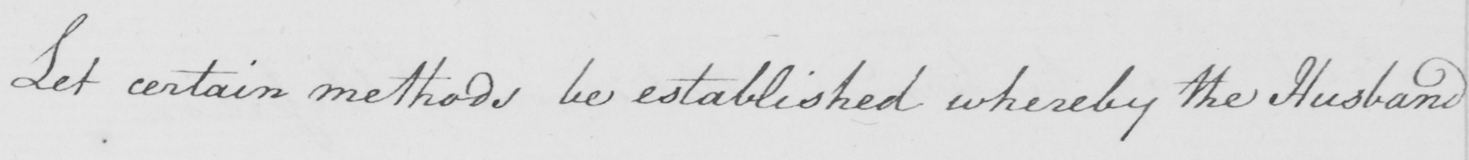Can you read and transcribe this handwriting? Let certain methods be established whereby the Husband 